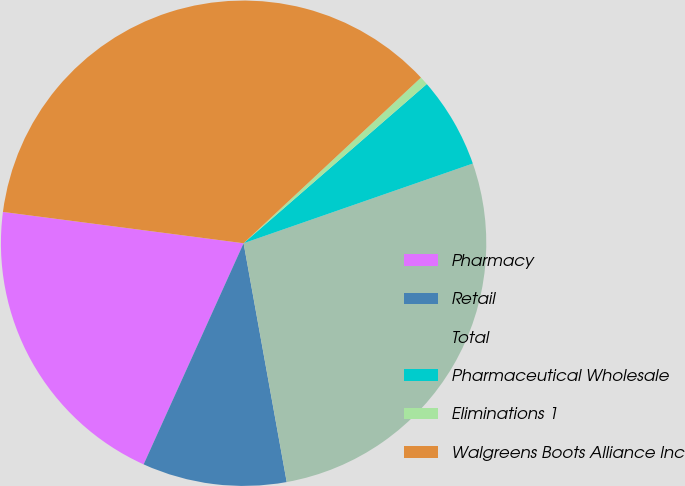Convert chart to OTSL. <chart><loc_0><loc_0><loc_500><loc_500><pie_chart><fcel>Pharmacy<fcel>Retail<fcel>Total<fcel>Pharmaceutical Wholesale<fcel>Eliminations 1<fcel>Walgreens Boots Alliance Inc<nl><fcel>20.3%<fcel>9.6%<fcel>27.48%<fcel>6.06%<fcel>0.57%<fcel>35.98%<nl></chart> 